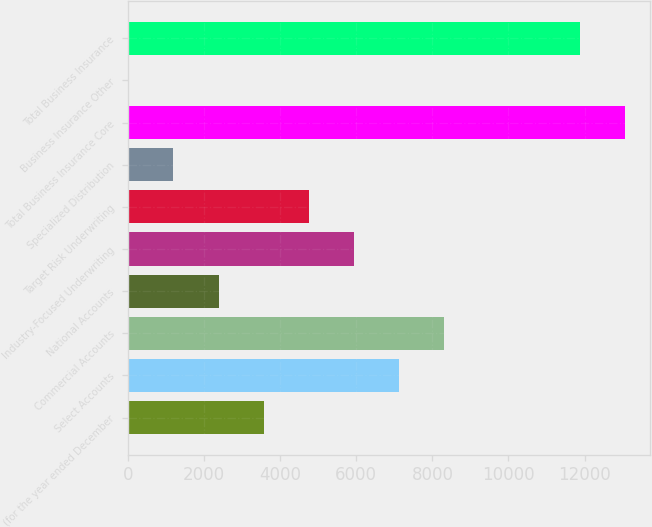Convert chart. <chart><loc_0><loc_0><loc_500><loc_500><bar_chart><fcel>(for the year ended December<fcel>Select Accounts<fcel>Commercial Accounts<fcel>National Accounts<fcel>Industry-Focused Underwriting<fcel>Target Risk Underwriting<fcel>Specialized Distribution<fcel>Total Business Insurance Core<fcel>Business Insurance Other<fcel>Total Business Insurance<nl><fcel>3562.6<fcel>7124.2<fcel>8311.4<fcel>2375.4<fcel>5937<fcel>4749.8<fcel>1188.2<fcel>13059.2<fcel>1<fcel>11872<nl></chart> 